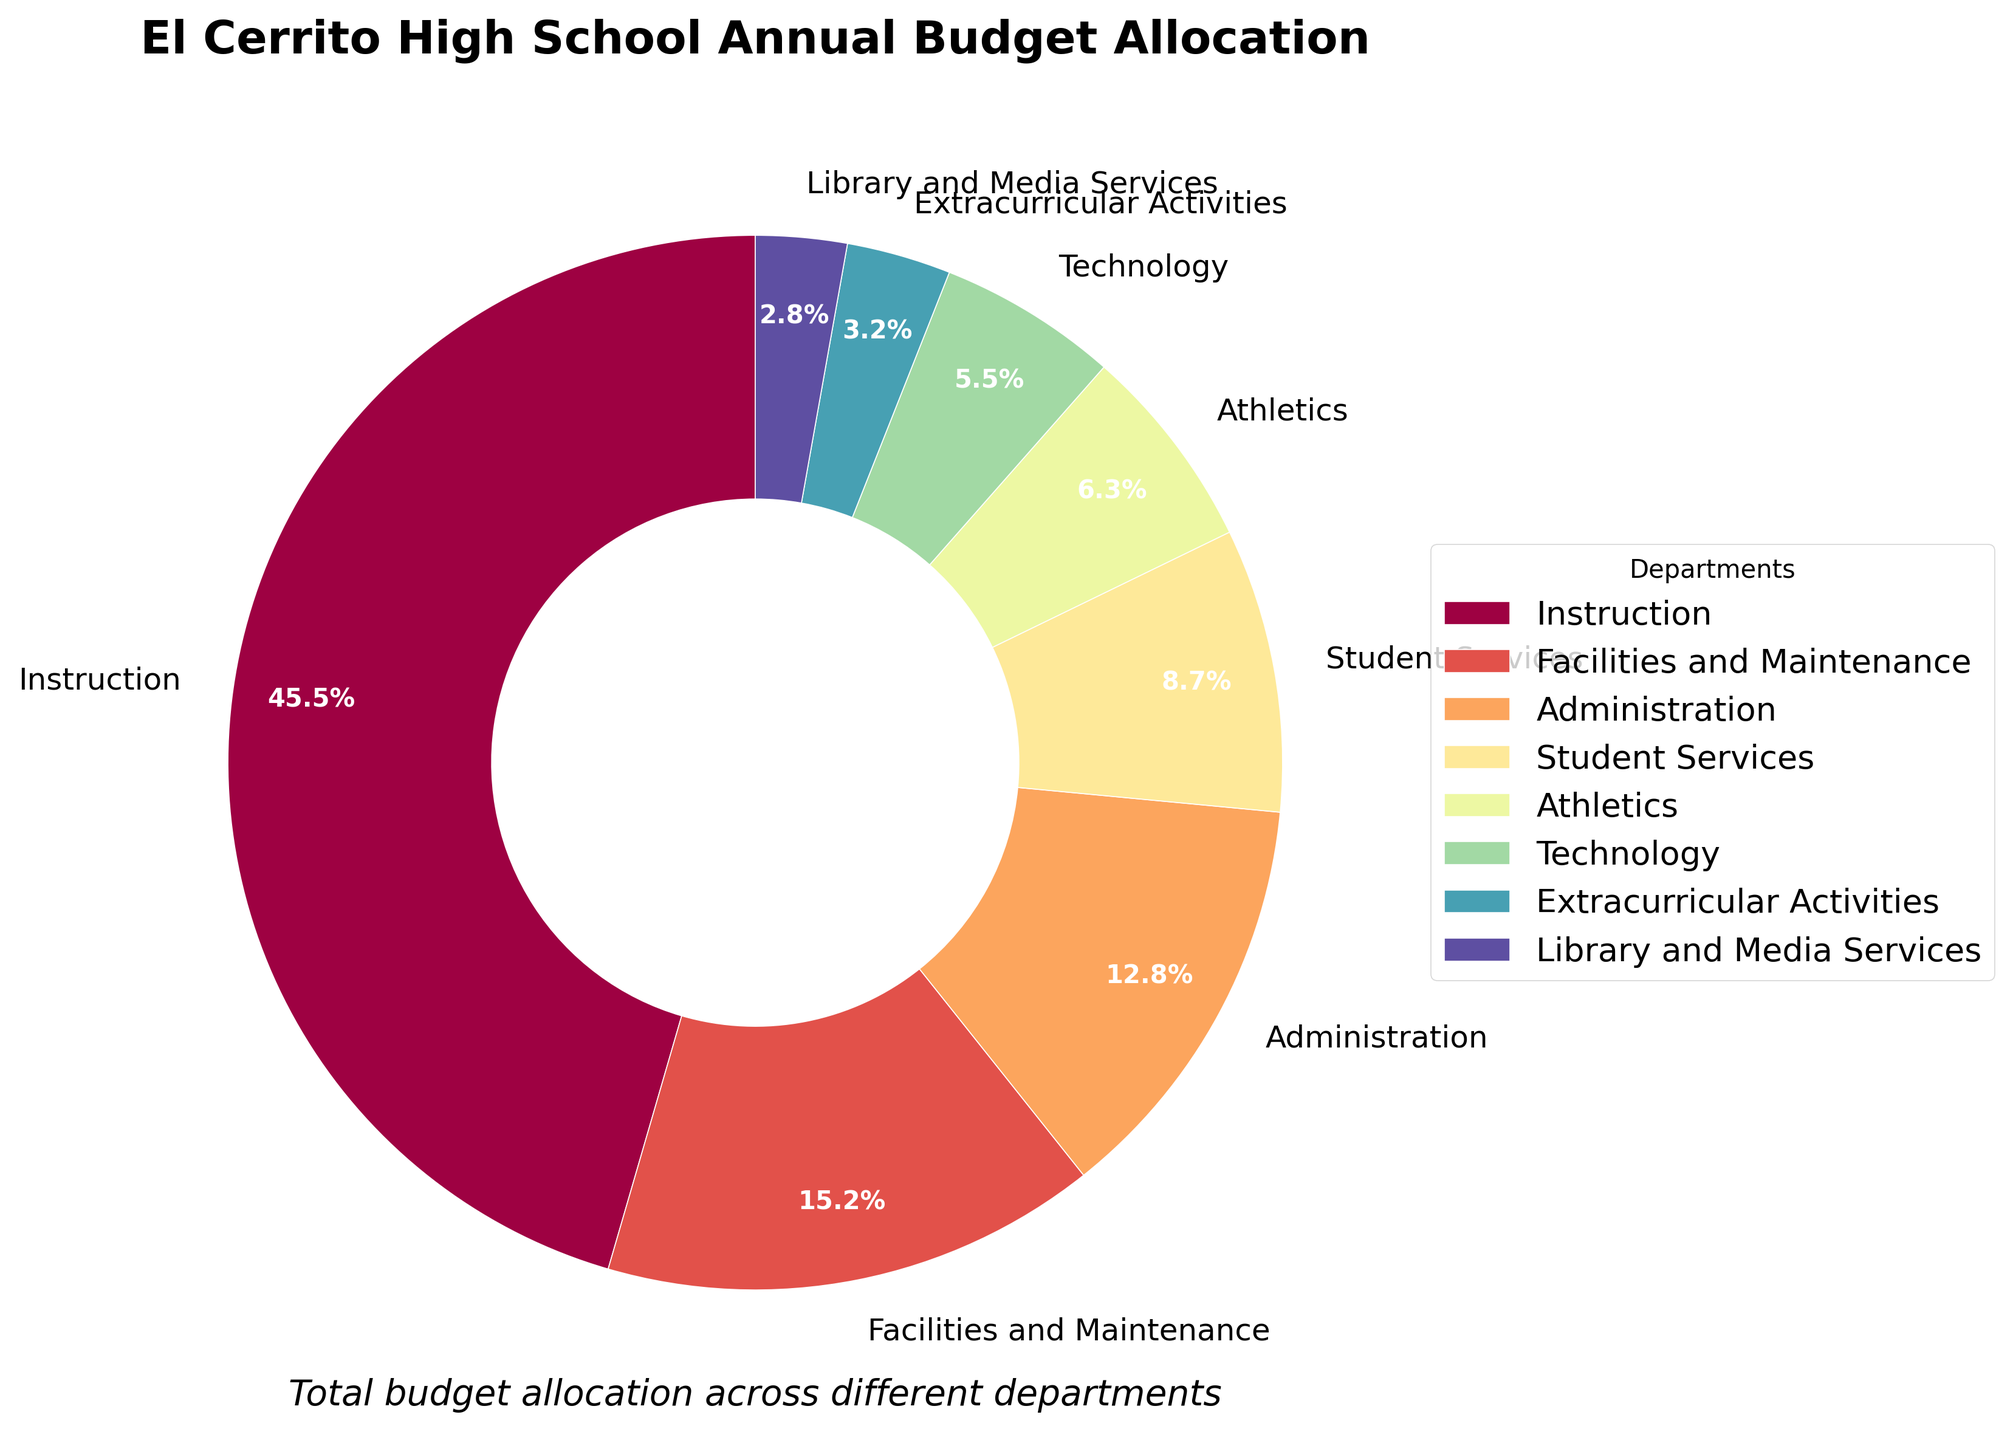Which department receives the largest allocation of the budget? The largest segment in the pie chart represents the department with the highest budget allocation. By observing the chart, the Instruction department has the largest segment.
Answer: Instruction Which department has a smaller budget allocation: Technology or Student Services? By observing the pie chart, compare the sizes of the segments labeled Technology and Student Services. The Student Services segment is larger than the Technology segment.
Answer: Technology What is the combined budget allocation for Facilities and Maintenance and Technology? Add the budget allocations for Facilities and Maintenance (15.2%) and Technology (5.5%). The combined allocation is 15.2% + 5.5% = 20.7%.
Answer: 20.7% By how much does the Administration's budget allocation exceed that of Athletics? Subtract the percentage of the Athletics budget allocation (6.3%) from the Administration's budget allocation (12.8%). The difference is 12.8% - 6.3% = 6.5%.
Answer: 6.5% Which two departments have the smallest budget allocations, and what is their combined allocation? Find the two smallest segments in the pie chart. These are Library and Media Services (2.8%) and Extracurricular Activities (3.2%). Their combined allocation is 2.8% + 3.2% = 6.0%.
Answer: Library and Media Services and Extracurricular Activities; 6.0% Is the budget allocation for Administration greater than, less than, or equal to the combined budget of Athletics and Library and Media Services? Add the budget allocations for Athletics (6.3%) and Library and Media Services (2.8%). The combined allocation is 6.3% + 2.8% = 9.1%. Since 12.8% (Administration) > 9.1%, Administration's allocation is greater.
Answer: Greater If the budget for Student Services doubled, would it exceed the budget for Facilities and Maintenance? Double the allocation for Student Services: 8.7% * 2 = 17.4%. The allocation for Facilities and Maintenance is 15.2%. Since 17.4% > 15.2%, the doubled allocation for Student Services would exceed Facilities and Maintenance.
Answer: Yes What is the total budget allocation for Instruction, Administration, and Athletics combined? Add the budget allocations for Instruction (45.5%), Administration (12.8%), and Athletics (6.3%). The total is 45.5% + 12.8% + 6.3% = 64.6%.
Answer: 64.6% Which department has approximately half the budget allocation of the Instruction department? Determine which department's allocation is about half of the Instruction's allocation (45.5%). Half of 45.5% is roughly 22.75%. No department has exactly 22.75%, but Administration (12.8%) is the closest to being a significant portion. However, no single department has half the allocation of Instruction; thus, the nearest value would be Technology if rounded down but not precisely half.
Answer: None; closest is Technology How much more is allocated to Facilities and Maintenance compared to Extracurricular Activities? Subtract the budget allocation for Extracurricular Activities (3.2%) from Facilities and Maintenance (15.2%). The difference is 15.2% - 3.2% = 12.0%.
Answer: 12.0% 